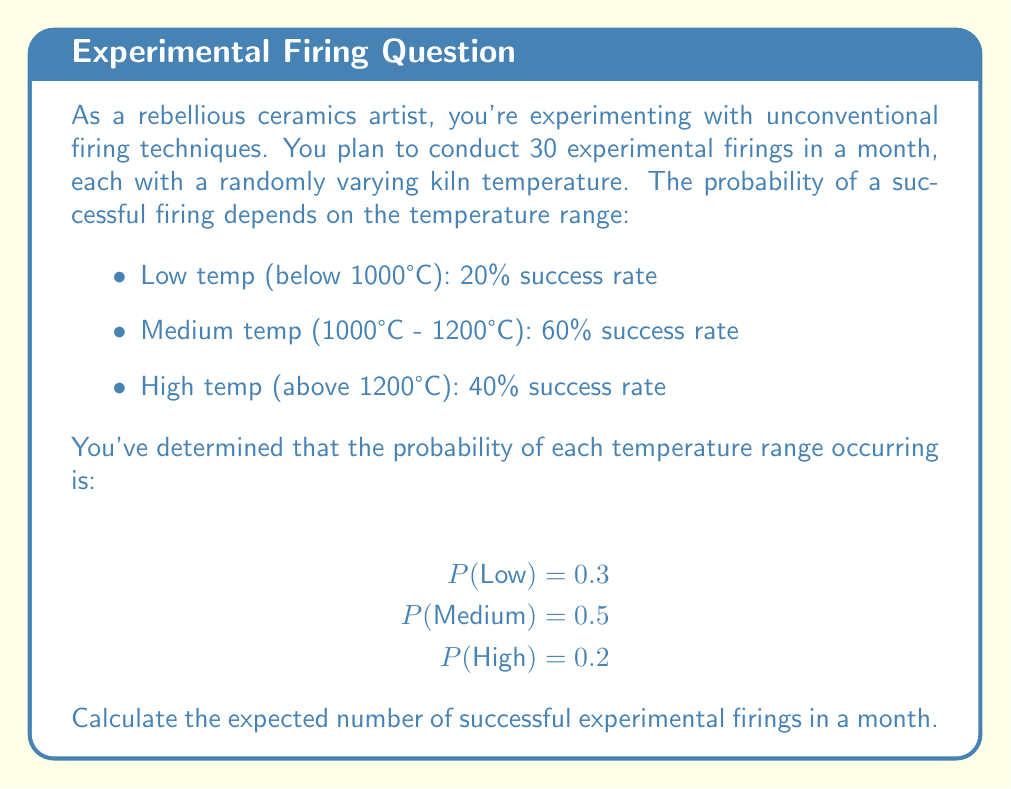Provide a solution to this math problem. To solve this problem, we'll use the concept of expected value for a random variable. Let's break it down step-by-step:

1) First, we need to calculate the overall probability of success for a single firing:

   P(Success) = P(Success|Low) * P(Low) + P(Success|Medium) * P(Medium) + P(Success|High) * P(High)

   $$ P(Success) = (0.20 \times 0.3) + (0.60 \times 0.5) + (0.40 \times 0.2) $$
   $$ = 0.06 + 0.30 + 0.08 = 0.44 $$

2) Now, we can treat each firing as a Bernoulli trial with probability of success p = 0.44.

3) The number of successful firings in 30 trials follows a Binomial distribution with n = 30 and p = 0.44.

4) The expected value of a Binomial distribution is given by:

   $$ E(X) = np $$

   Where n is the number of trials and p is the probability of success.

5) Plugging in our values:

   $$ E(X) = 30 \times 0.44 = 13.2 $$

Therefore, the expected number of successful experimental firings in a month is 13.2.
Answer: 13.2 successful firings 